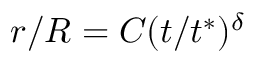<formula> <loc_0><loc_0><loc_500><loc_500>r / R = C ( t / t ^ { * } ) ^ { \delta }</formula> 